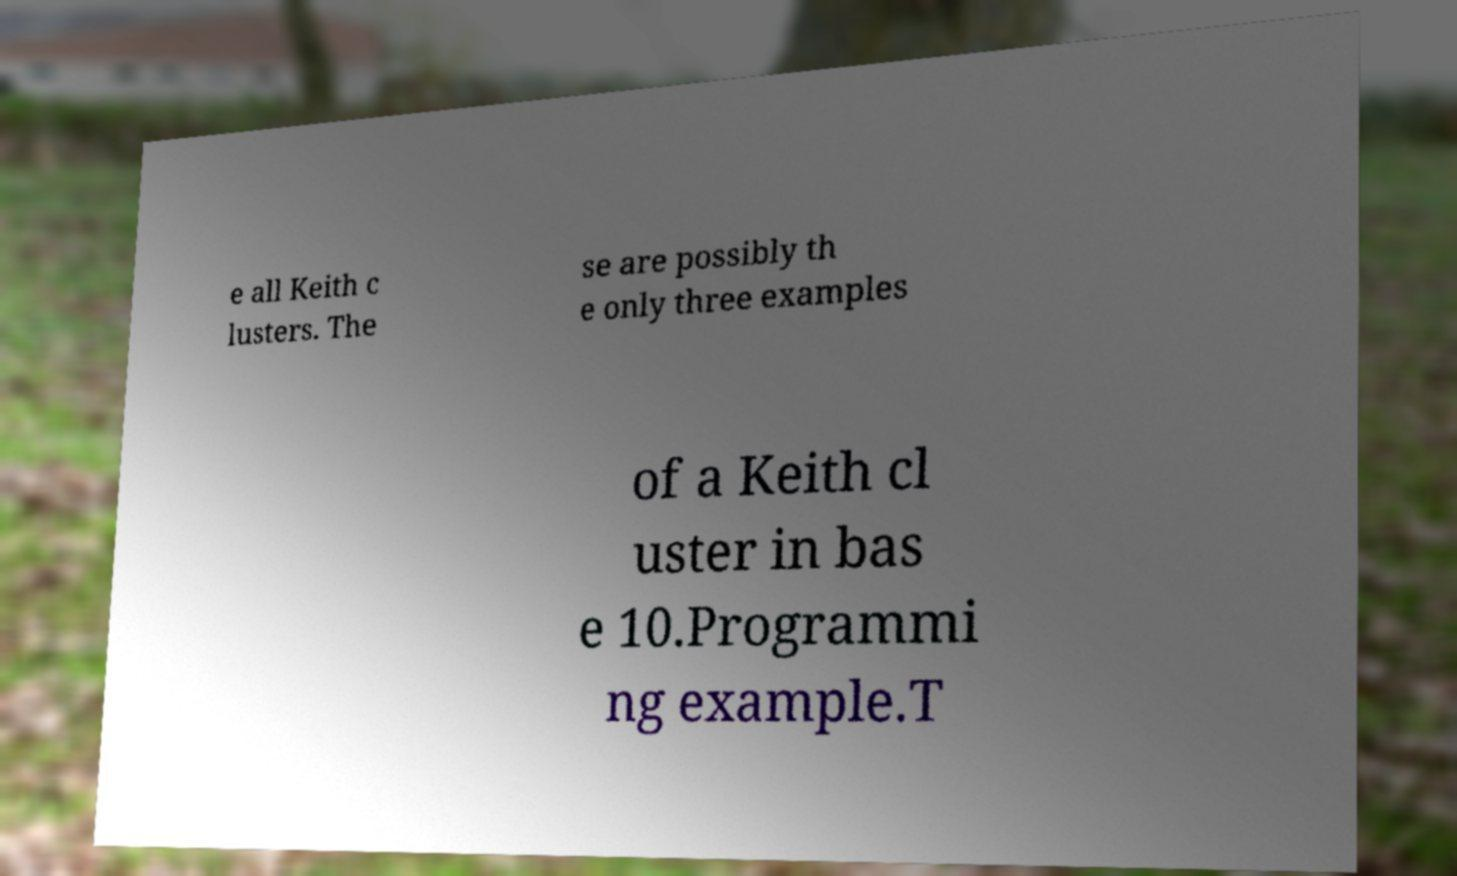Please identify and transcribe the text found in this image. e all Keith c lusters. The se are possibly th e only three examples of a Keith cl uster in bas e 10.Programmi ng example.T 